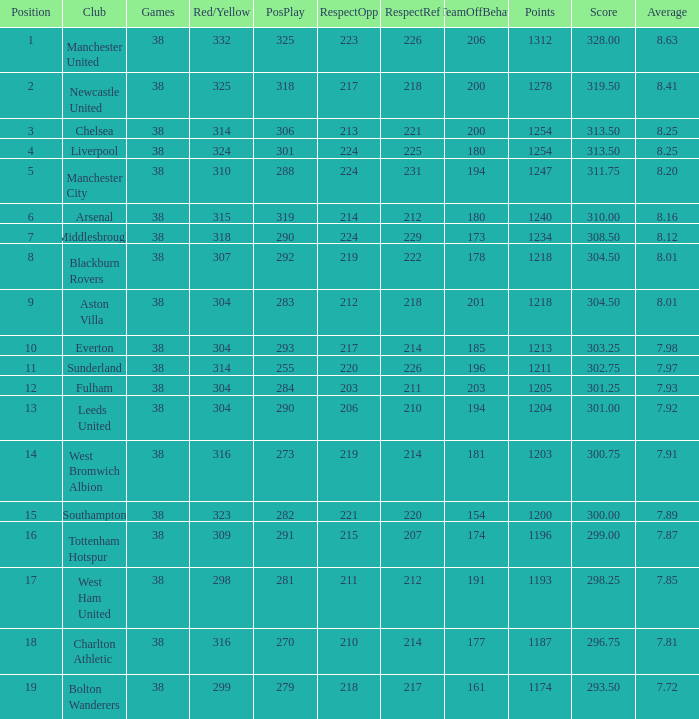What is the post for west ham united? 17.0. 